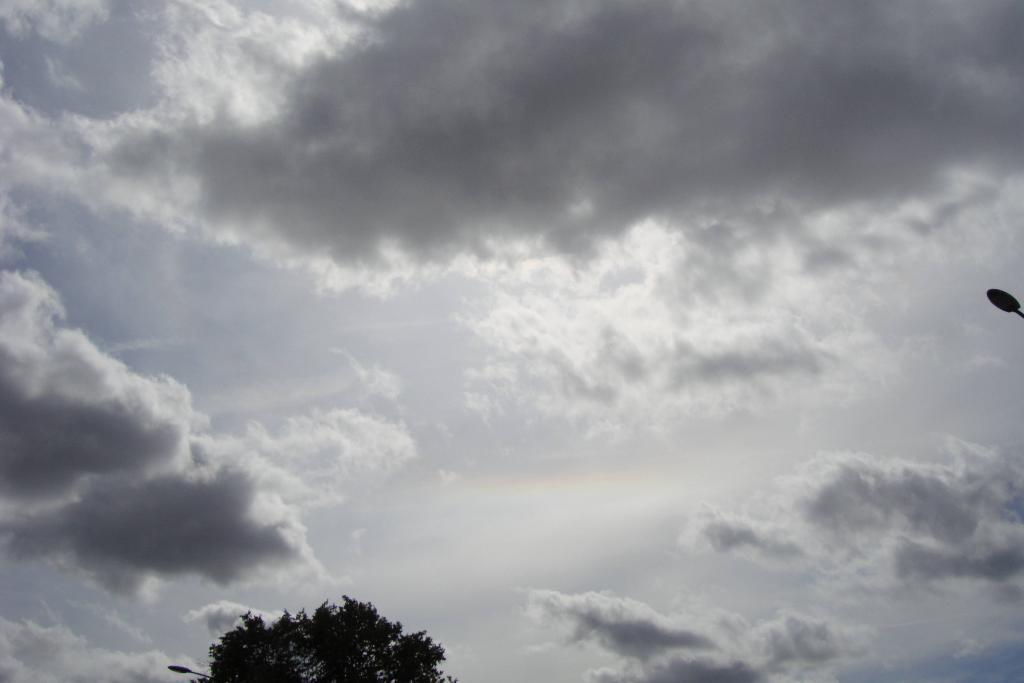Could you give a brief overview of what you see in this image? In this image we can see a tree, some light poles and the cloudy sky. 